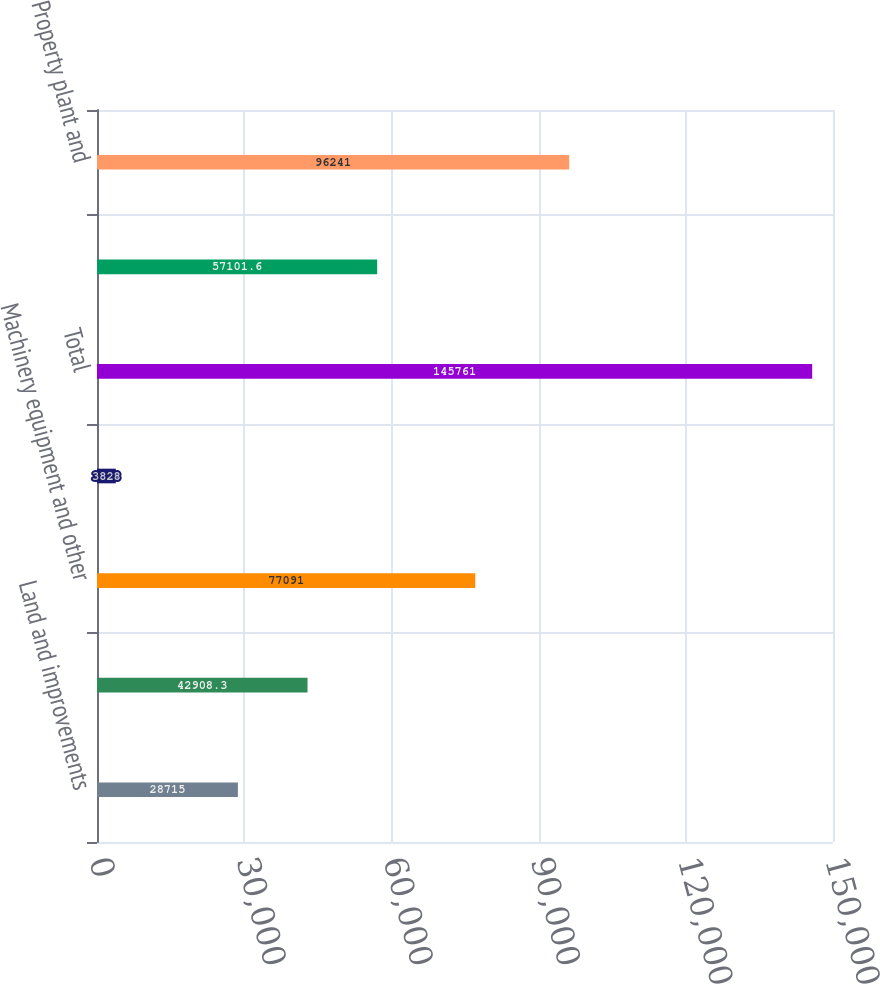<chart> <loc_0><loc_0><loc_500><loc_500><bar_chart><fcel>Land and improvements<fcel>Buildings and improvements<fcel>Machinery equipment and other<fcel>Construction in progress<fcel>Total<fcel>Accumulated depreciation<fcel>Property plant and<nl><fcel>28715<fcel>42908.3<fcel>77091<fcel>3828<fcel>145761<fcel>57101.6<fcel>96241<nl></chart> 